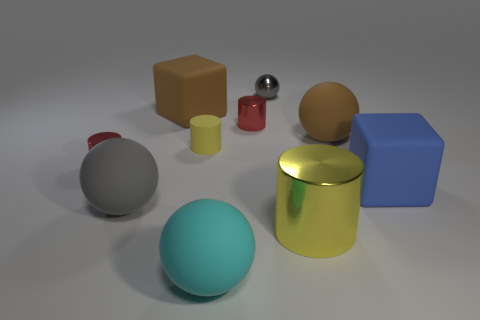How many red objects are in front of the small cylinder that is in front of the tiny matte cylinder? There appears to be one red object—a small cylinder—in front of the small shiny cylinder, which itself is situated in front of the tiny matte cylinder. 